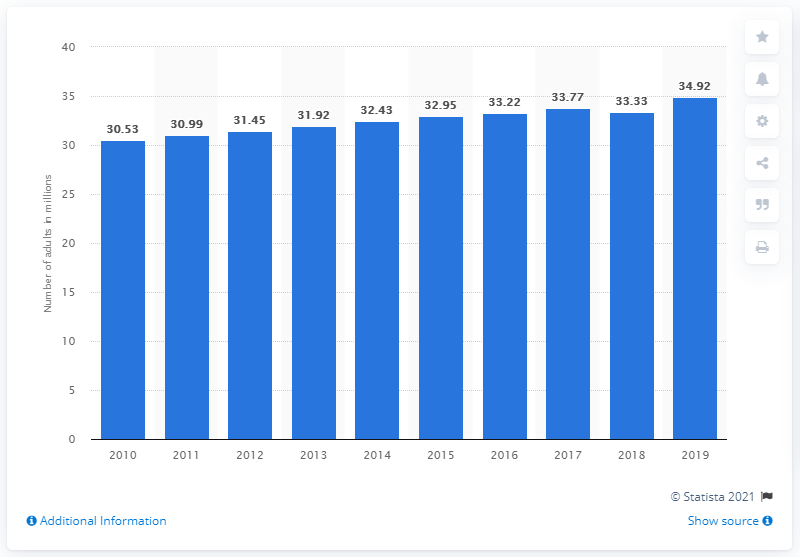Give some essential details in this illustration. In 2019, there were approximately 34.92 million adults in Myanmar. 